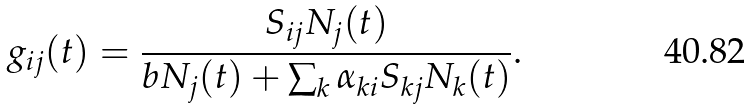Convert formula to latex. <formula><loc_0><loc_0><loc_500><loc_500>g _ { i j } ( t ) = \frac { S _ { i j } N _ { j } ( t ) } { b N _ { j } ( t ) + \sum _ { k } \alpha _ { k i } S _ { k j } N _ { k } ( t ) } .</formula> 